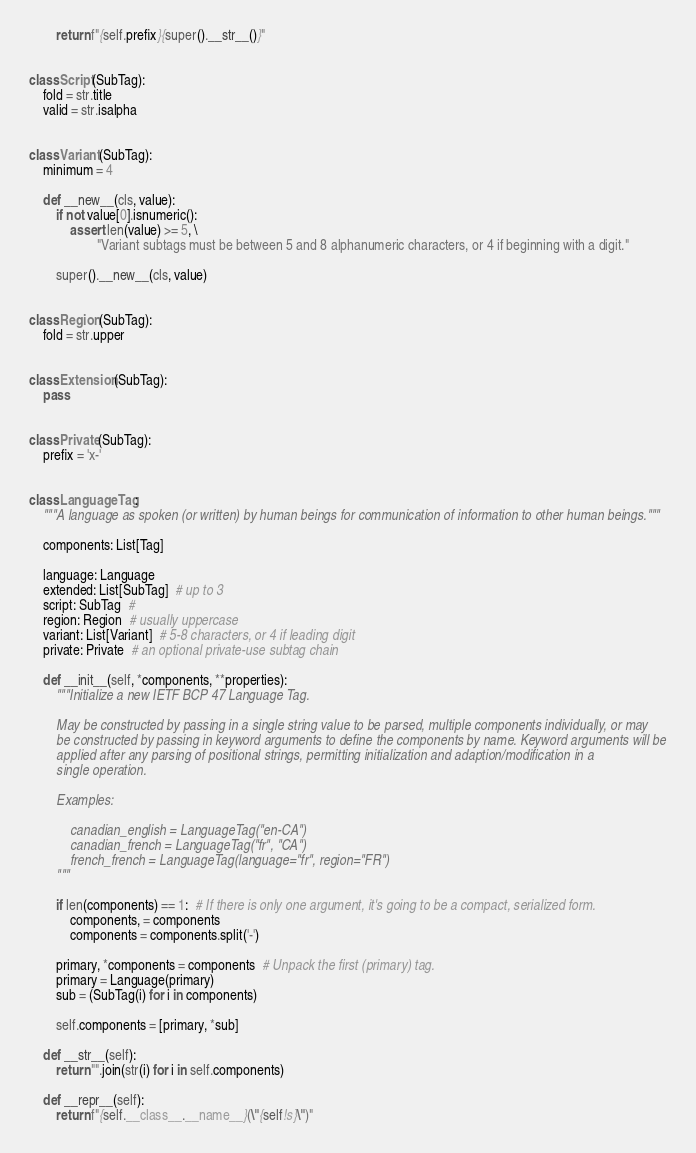Convert code to text. <code><loc_0><loc_0><loc_500><loc_500><_Python_>		return f"{self.prefix}{super().__str__()}"


class Script(SubTag):
	fold = str.title
	valid = str.isalpha


class Variant(SubTag):
	minimum = 4
	
	def __new__(cls, value):
		if not value[0].isnumeric():
			assert len(value) >= 5, \
					"Variant subtags must be between 5 and 8 alphanumeric characters, or 4 if beginning with a digit."
		
		super().__new__(cls, value)


class Region(SubTag):
	fold = str.upper


class Extension(SubTag):
	pass


class Private(SubTag):
	prefix = 'x-'


class LanguageTag:
	"""A language as spoken (or written) by human beings for communication of information to other human beings."""
	
	components: List[Tag]
	
	language: Language
	extended: List[SubTag]  # up to 3
	script: SubTag  # 
	region: Region  # usually uppercase
	variant: List[Variant]  # 5-8 characters, or 4 if leading digit
	private: Private  # an optional private-use subtag chain
	
	def __init__(self, *components, **properties):
		"""Initialize a new IETF BCP 47 Language Tag.
		
		May be constructed by passing in a single string value to be parsed, multiple components individually, or may
		be constructed by passing in keyword arguments to define the components by name. Keyword arguments will be
		applied after any parsing of positional strings, permitting initialization and adaption/modification in a
		single operation.
		
		Examples:
		
			canadian_english = LanguageTag("en-CA")
			canadian_french = LanguageTag("fr", "CA")
			french_french = LanguageTag(language="fr", region="FR")
		"""
		
		if len(components) == 1:  # If there is only one argument, it's going to be a compact, serialized form.
			components, = components
			components = components.split('-')
		
		primary, *components = components  # Unpack the first (primary) tag.
		primary = Language(primary)
		sub = (SubTag(i) for i in components)
		
		self.components = [primary, *sub]
	
	def __str__(self):
		return "".join(str(i) for i in self.components)
	
	def __repr__(self):
		return f"{self.__class__.__name__}(\"{self!s}\")"
</code> 